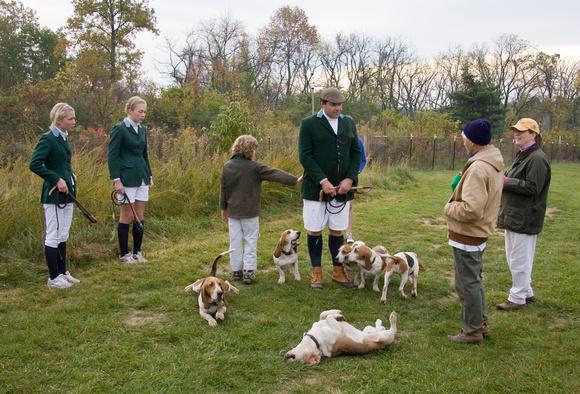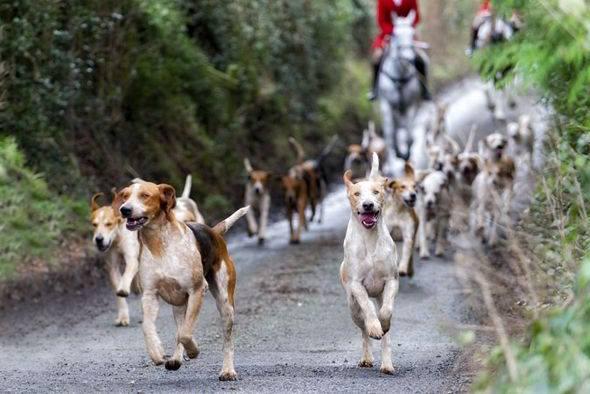The first image is the image on the left, the second image is the image on the right. For the images displayed, is the sentence "A person in white pants and a dark green jacket is standing near hounds and holding a whip in one of the images." factually correct? Answer yes or no. Yes. 